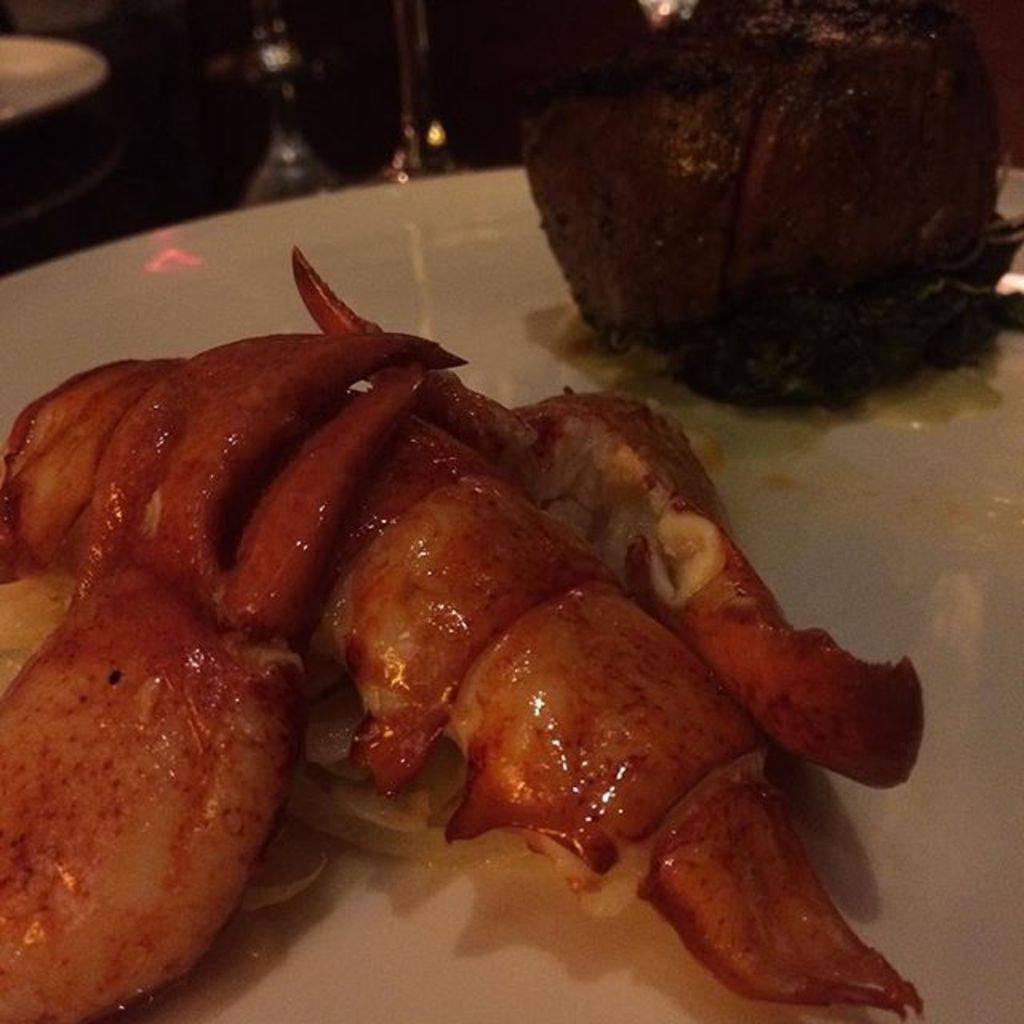What is present on the plate in the image? There are eatables on the plate in the image. What is the color of the plate? The plate is white in color. How many children are playing with tomatoes in the image? There are no children or tomatoes present in the image. 